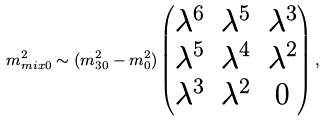Convert formula to latex. <formula><loc_0><loc_0><loc_500><loc_500>m ^ { 2 } _ { m i x 0 } \sim ( m ^ { 2 } _ { 3 0 } - m ^ { 2 } _ { 0 } ) \begin{pmatrix} \lambda ^ { 6 } & \lambda ^ { 5 } & \lambda ^ { 3 } \\ \lambda ^ { 5 } & \lambda ^ { 4 } & \lambda ^ { 2 } \\ \lambda ^ { 3 } & \lambda ^ { 2 } & 0 \end{pmatrix} ,</formula> 